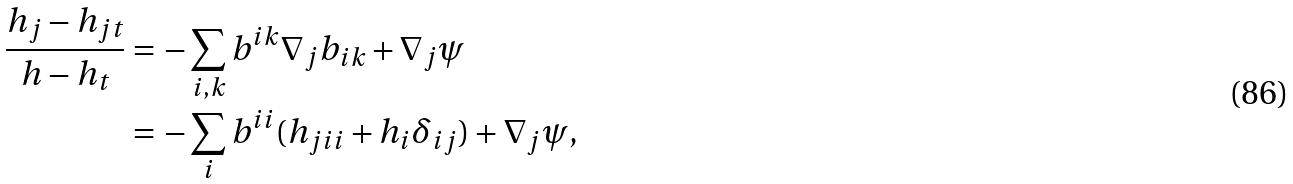<formula> <loc_0><loc_0><loc_500><loc_500>\frac { h _ { j } - h _ { j t } } { h - h _ { t } } & = - \sum _ { i , k } b ^ { i k } \nabla _ { j } b _ { i k } + \nabla _ { j } \psi \\ & = - \sum _ { i } b ^ { i i } ( h _ { j i i } + h _ { i } \delta _ { i j } ) + \nabla _ { j } \psi ,</formula> 